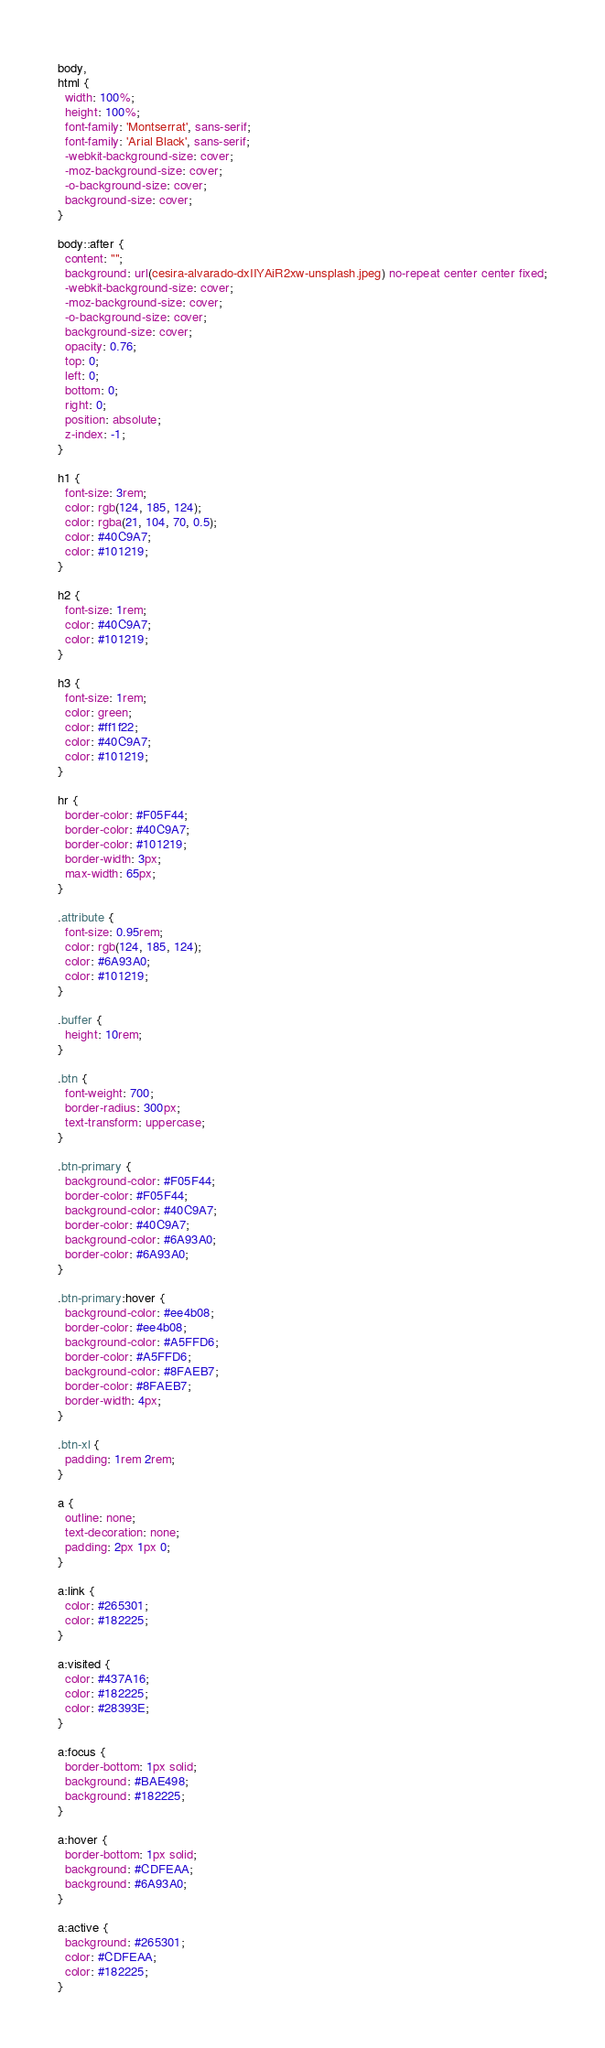Convert code to text. <code><loc_0><loc_0><loc_500><loc_500><_CSS_>body,
html {
  width: 100%;
  height: 100%;
  font-family: 'Montserrat', sans-serif;
  font-family: 'Arial Black', sans-serif;
  -webkit-background-size: cover;
  -moz-background-size: cover;
  -o-background-size: cover;
  background-size: cover;
}

body::after {
  content: "";
  background: url(cesira-alvarado-dxIIYAiR2xw-unsplash.jpeg) no-repeat center center fixed;
  -webkit-background-size: cover;
  -moz-background-size: cover;
  -o-background-size: cover;
  background-size: cover;
  opacity: 0.76;
  top: 0;
  left: 0;
  bottom: 0;
  right: 0;
  position: absolute;
  z-index: -1;   
}

h1 {
  font-size: 3rem;
  color: rgb(124, 185, 124);
  color: rgba(21, 104, 70, 0.5);
  color: #40C9A7;
  color: #101219;
}

h2 {
  font-size: 1rem;
  color: #40C9A7;
  color: #101219;
}

h3 {
  font-size: 1rem;
  color: green;
  color: #ff1f22;
  color: #40C9A7;
  color: #101219;
}

hr {
  border-color: #F05F44;
  border-color: #40C9A7;
  border-color: #101219;
  border-width: 3px;
  max-width: 65px;
}

.attribute {
  font-size: 0.95rem;
  color: rgb(124, 185, 124);
  color: #6A93A0;
  color: #101219;
}

.buffer {
  height: 10rem;
}

.btn {
  font-weight: 700;
  border-radius: 300px;
  text-transform: uppercase;
}

.btn-primary {
  background-color: #F05F44;
  border-color: #F05F44;
  background-color: #40C9A7;
  border-color: #40C9A7;
  background-color: #6A93A0;
  border-color: #6A93A0;
}

.btn-primary:hover {
  background-color: #ee4b08;
  border-color: #ee4b08;
  background-color: #A5FFD6;
  border-color: #A5FFD6;
  background-color: #8FAEB7;
  border-color: #8FAEB7;
  border-width: 4px;
}

.btn-xl {
  padding: 1rem 2rem;
}

a {
  outline: none;
  text-decoration: none;
  padding: 2px 1px 0;
}

a:link {
  color: #265301;
  color: #182225;
}

a:visited {
  color: #437A16;
  color: #182225;
  color: #28393E;
}

a:focus {
  border-bottom: 1px solid;
  background: #BAE498;
  background: #182225;
}

a:hover {
  border-bottom: 1px solid;
  background: #CDFEAA;
  background: #6A93A0;
}

a:active {
  background: #265301;
  color: #CDFEAA;
  color: #182225;
}</code> 